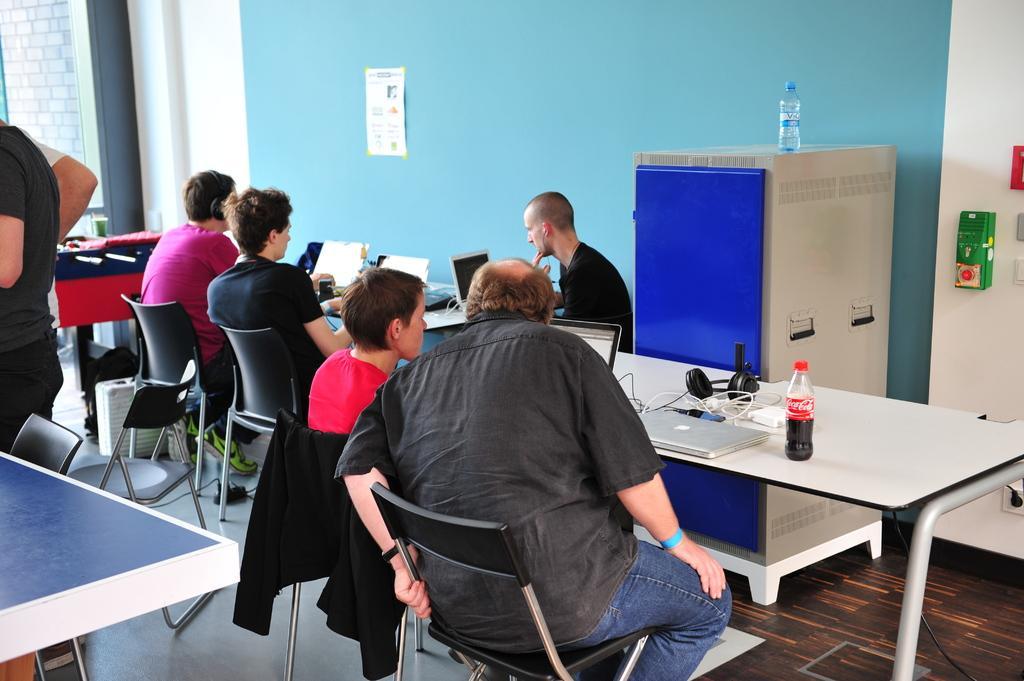Can you describe this image briefly? People are sitting at different tables and working in their laptops. 